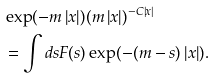Convert formula to latex. <formula><loc_0><loc_0><loc_500><loc_500>& \exp ( - m \left | x \right | ) ( m \left | x \right | ) ^ { - C \left | x \right | } \\ & = \int d s F ( s ) \exp ( - ( m - s ) \left | x \right | ) .</formula> 